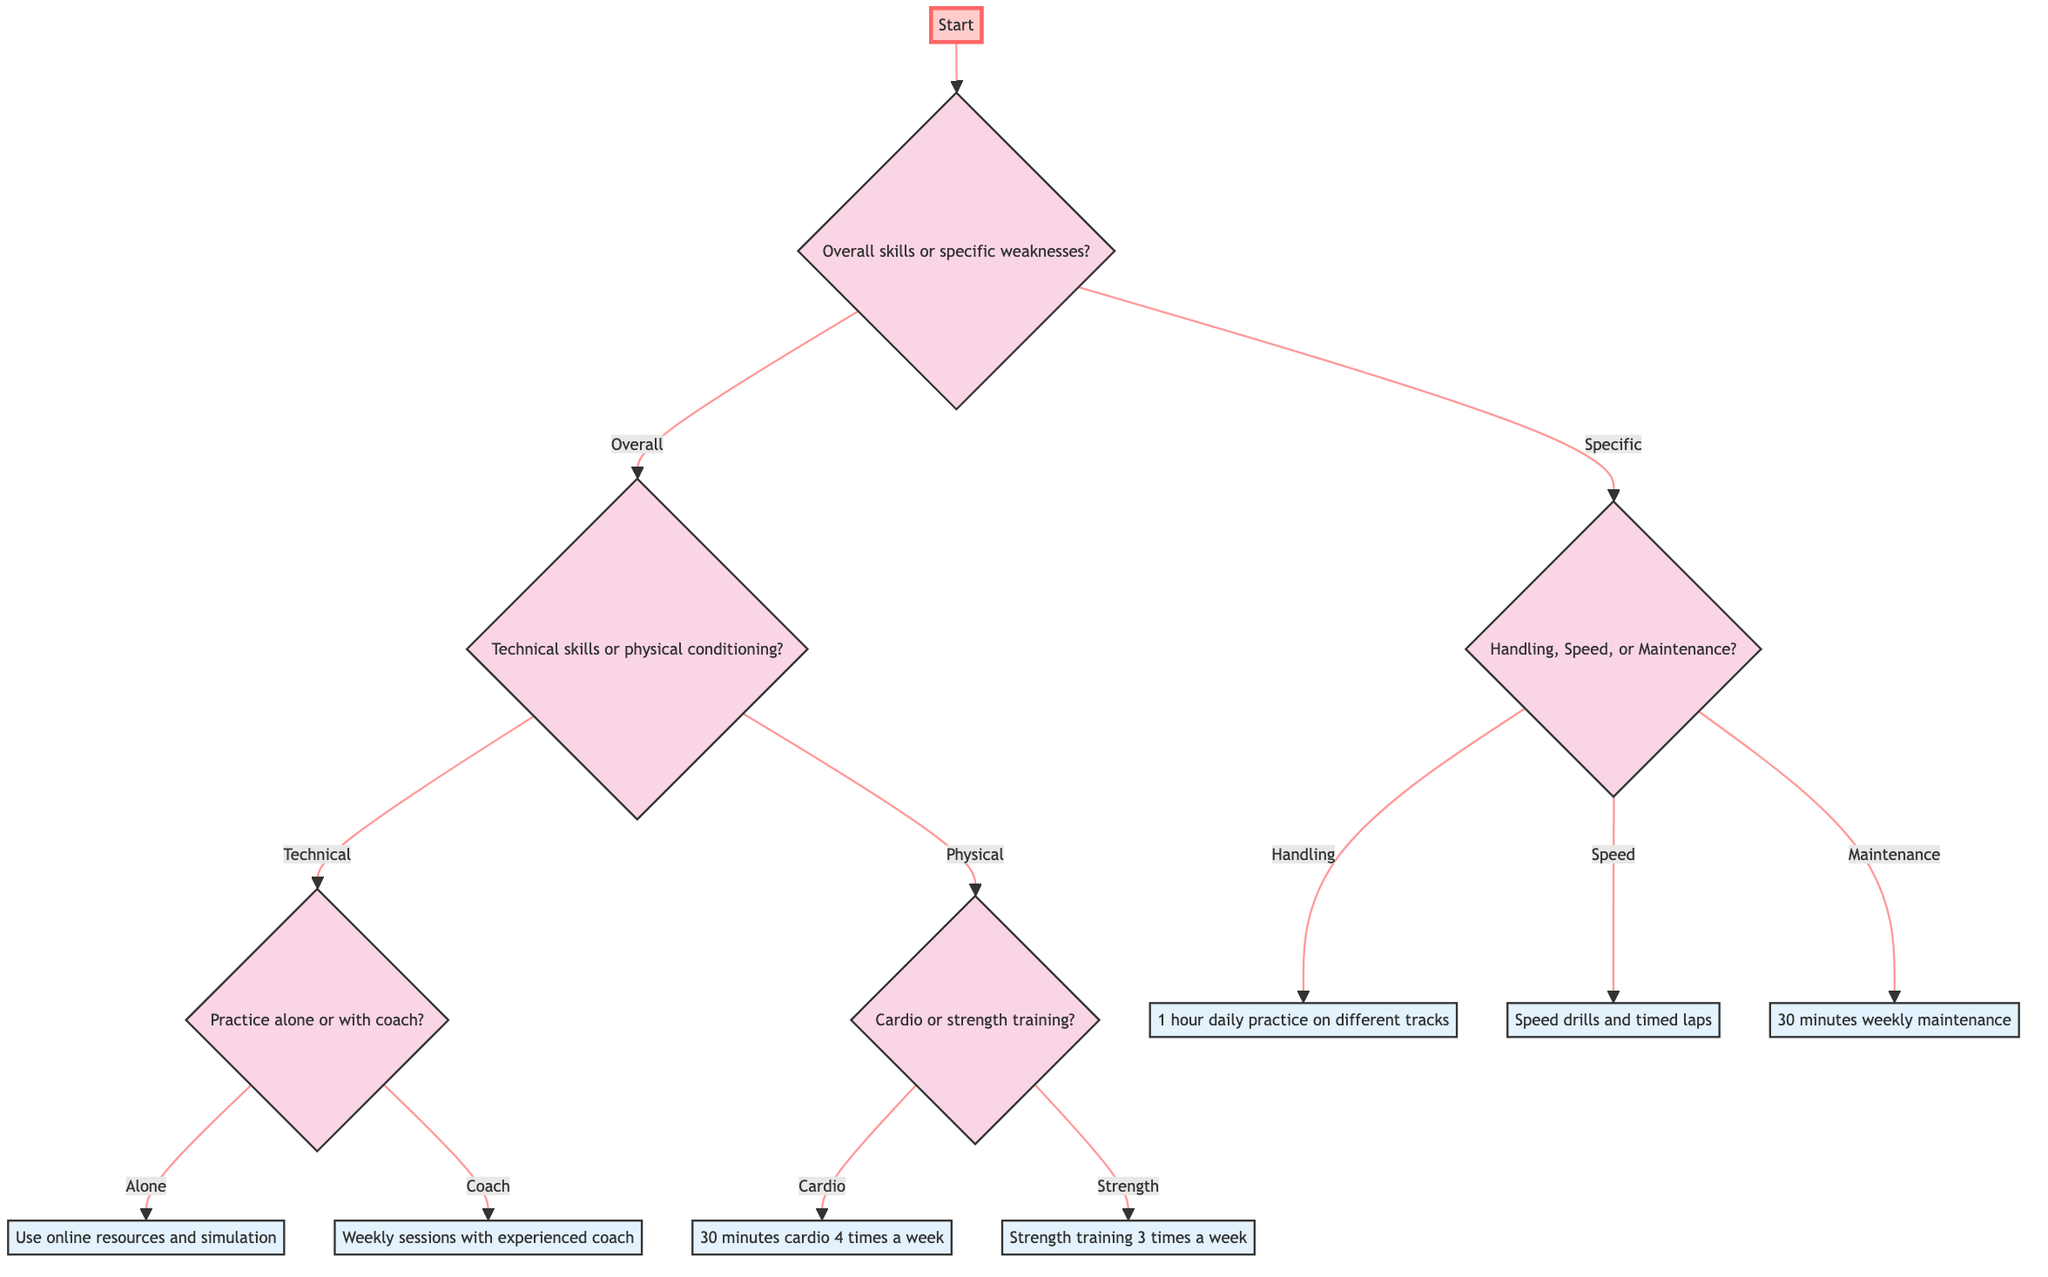What options are available for improving skills? The diagram starts with a question about improving overall skills or addressing specific weaknesses. The two main branches are "Overall Skills" and "Specific Weaknesses" based on the initial decision.
Answer: Overall Skills, Specific Weaknesses How many areas can you improve under Specific Weaknesses? The Specific Weaknesses node presents three options: Handling, Speed, and Maintenance. Counting these gives the total number of areas that can be improved.
Answer: Three What action is suggested for improving Handling? Following the path from Specific Weaknesses to Handling, it shows the recommended action of allocating time for daily practice specifically focusing on handling techniques.
Answer: Allocate 1 hour daily to practice advanced steering techniques on different track layouts If I choose to improve my Technical Skills, what are my options for practice? The path leads from Technical Skills to the question of whether to practice Alone or with a Coach, indicating the two methods available for skill improvement in this area.
Answer: Alone, With Coach What should I focus on if I want to improve my physical conditioning? The diagram shows that if physical conditioning is the focus, the next decision branches into Cardio Workouts or Strength Training. This step can be traced back through the flow of the diagram as well.
Answer: Cardio Workouts, Strength Training How many total actions are recommended in the diagram? Counting the number of distinct actions associated with the end nodes—including "1 hour daily practice on different tracks," "Speed drills and timed laps," "30 minutes weekly maintenance," "Use online resources and simulation," and "Weekly sessions with experienced coach"—yields the answer.
Answer: Six What can I do if I decide to practice with a coach? Following the flow from the option to practice with a coach under Technical Skills leads directly to the suggested action of scheduling weekly sessions, which provides a straightforward recommendation.
Answer: Schedule weekly sessions with an experienced RC car coach What type of workouts are suggested for improving stamina? If you follow the path for physical conditioning to the option for cardio workouts, it specifically mentions including a cardio routine to enhance stamina.
Answer: Include 30 minutes of cardio, such as running or cycling, 4 times a week to improve stamina If I want to strengthen my upper body, what action should I take? Tracing the decision for physical conditioning toward strength training leads to the specific recommendation focused on core and upper body exercises, outlining the intended area of improvement.
Answer: Engage in strength training exercises focusing on core and upper body, 3 times a week 